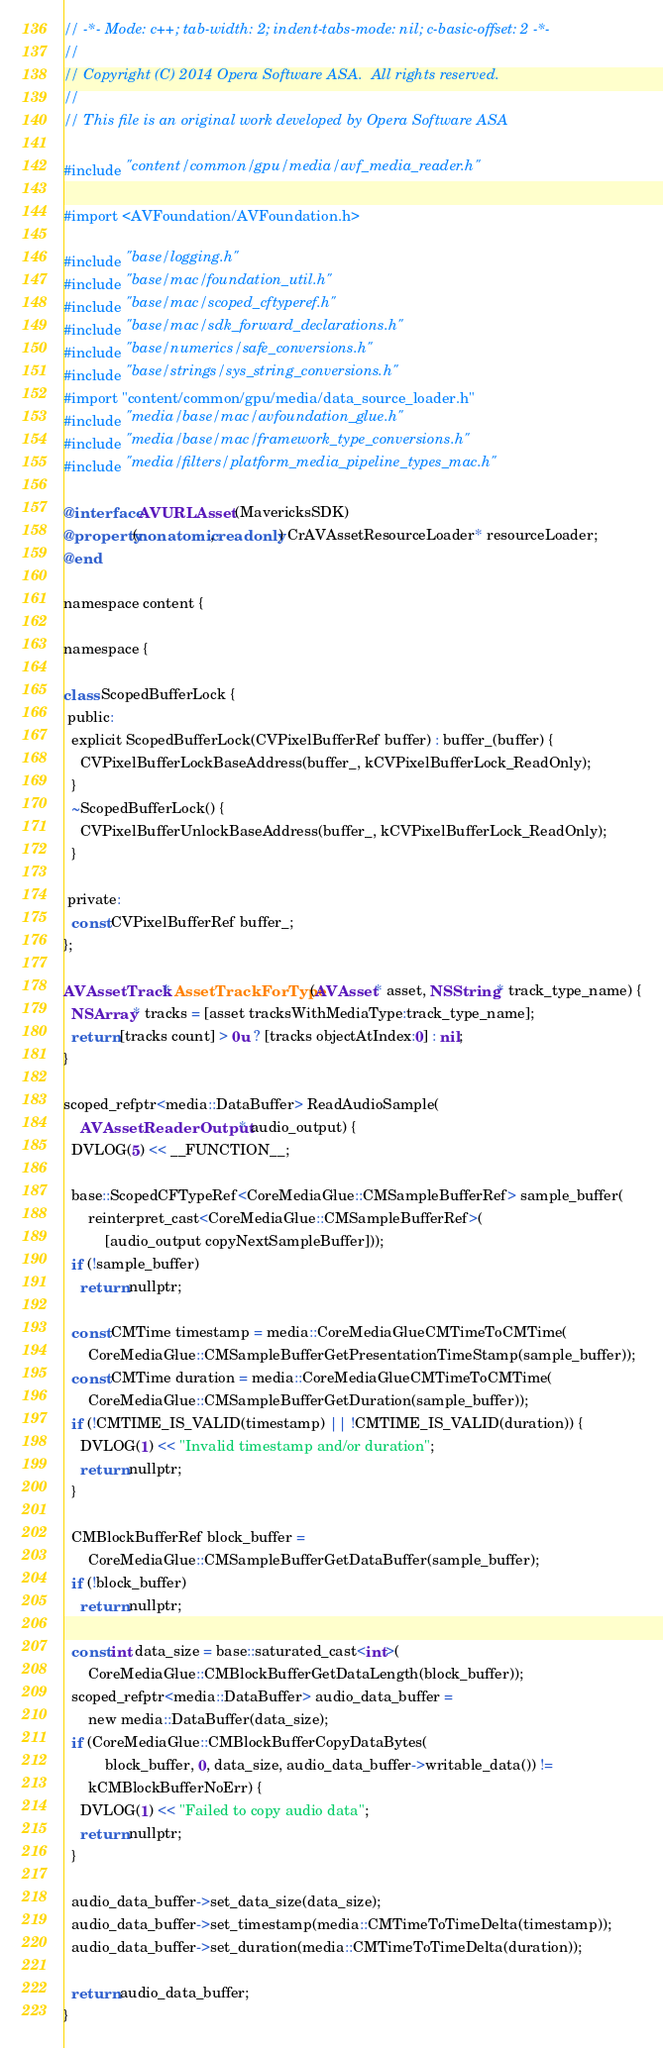<code> <loc_0><loc_0><loc_500><loc_500><_ObjectiveC_>// -*- Mode: c++; tab-width: 2; indent-tabs-mode: nil; c-basic-offset: 2 -*-
//
// Copyright (C) 2014 Opera Software ASA.  All rights reserved.
//
// This file is an original work developed by Opera Software ASA

#include "content/common/gpu/media/avf_media_reader.h"

#import <AVFoundation/AVFoundation.h>

#include "base/logging.h"
#include "base/mac/foundation_util.h"
#include "base/mac/scoped_cftyperef.h"
#include "base/mac/sdk_forward_declarations.h"
#include "base/numerics/safe_conversions.h"
#include "base/strings/sys_string_conversions.h"
#import "content/common/gpu/media/data_source_loader.h"
#include "media/base/mac/avfoundation_glue.h"
#include "media/base/mac/framework_type_conversions.h"
#include "media/filters/platform_media_pipeline_types_mac.h"

@interface AVURLAsset (MavericksSDK)
@property(nonatomic, readonly) CrAVAssetResourceLoader* resourceLoader;
@end

namespace content {

namespace {

class ScopedBufferLock {
 public:
  explicit ScopedBufferLock(CVPixelBufferRef buffer) : buffer_(buffer) {
    CVPixelBufferLockBaseAddress(buffer_, kCVPixelBufferLock_ReadOnly);
  }
  ~ScopedBufferLock() {
    CVPixelBufferUnlockBaseAddress(buffer_, kCVPixelBufferLock_ReadOnly);
  }

 private:
  const CVPixelBufferRef buffer_;
};

AVAssetTrack* AssetTrackForType(AVAsset* asset, NSString* track_type_name) {
  NSArray* tracks = [asset tracksWithMediaType:track_type_name];
  return [tracks count] > 0u ? [tracks objectAtIndex:0] : nil;
}

scoped_refptr<media::DataBuffer> ReadAudioSample(
    AVAssetReaderOutput* audio_output) {
  DVLOG(5) << __FUNCTION__;

  base::ScopedCFTypeRef<CoreMediaGlue::CMSampleBufferRef> sample_buffer(
      reinterpret_cast<CoreMediaGlue::CMSampleBufferRef>(
          [audio_output copyNextSampleBuffer]));
  if (!sample_buffer)
    return nullptr;

  const CMTime timestamp = media::CoreMediaGlueCMTimeToCMTime(
      CoreMediaGlue::CMSampleBufferGetPresentationTimeStamp(sample_buffer));
  const CMTime duration = media::CoreMediaGlueCMTimeToCMTime(
      CoreMediaGlue::CMSampleBufferGetDuration(sample_buffer));
  if (!CMTIME_IS_VALID(timestamp) || !CMTIME_IS_VALID(duration)) {
    DVLOG(1) << "Invalid timestamp and/or duration";
    return nullptr;
  }

  CMBlockBufferRef block_buffer =
      CoreMediaGlue::CMSampleBufferGetDataBuffer(sample_buffer);
  if (!block_buffer)
    return nullptr;

  const int data_size = base::saturated_cast<int>(
      CoreMediaGlue::CMBlockBufferGetDataLength(block_buffer));
  scoped_refptr<media::DataBuffer> audio_data_buffer =
      new media::DataBuffer(data_size);
  if (CoreMediaGlue::CMBlockBufferCopyDataBytes(
          block_buffer, 0, data_size, audio_data_buffer->writable_data()) !=
      kCMBlockBufferNoErr) {
    DVLOG(1) << "Failed to copy audio data";
    return nullptr;
  }

  audio_data_buffer->set_data_size(data_size);
  audio_data_buffer->set_timestamp(media::CMTimeToTimeDelta(timestamp));
  audio_data_buffer->set_duration(media::CMTimeToTimeDelta(duration));

  return audio_data_buffer;
}
</code> 